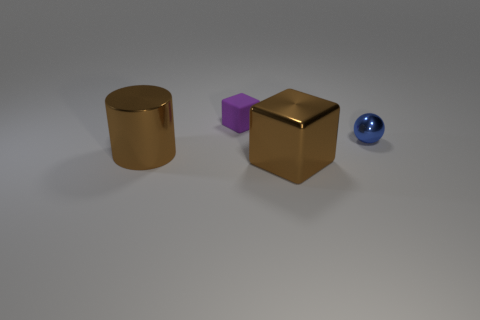What is the shape of the shiny object that is the same color as the cylinder?
Ensure brevity in your answer.  Cube. Are there any other things that are the same color as the shiny cylinder?
Keep it short and to the point. Yes. Are there an equal number of brown metal objects behind the big cube and blocks that are to the right of the large brown cylinder?
Give a very brief answer. No. There is a cube in front of the cube that is behind the small metal thing; what is its size?
Your response must be concise. Large. There is a object that is both left of the large block and on the right side of the big brown cylinder; what is it made of?
Ensure brevity in your answer.  Rubber. How many other things are the same size as the blue thing?
Your response must be concise. 1. What is the color of the matte object?
Ensure brevity in your answer.  Purple. There is a block that is on the right side of the purple matte thing; does it have the same color as the thing on the left side of the tiny purple matte cube?
Provide a succinct answer. Yes. What size is the cylinder?
Your answer should be very brief. Large. There is a block that is in front of the blue sphere; what size is it?
Provide a short and direct response. Large. 